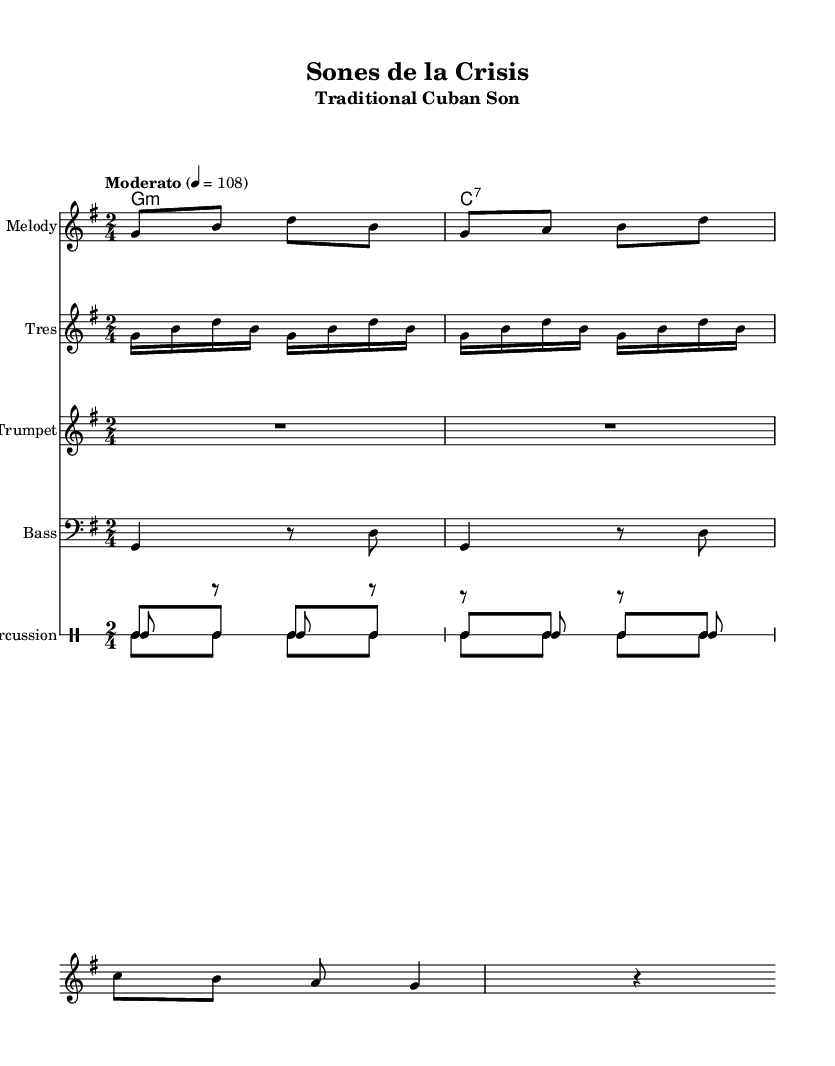What is the key signature of this music? The key signature is G major, indicated by one sharp (F#) on the staff.
Answer: G major What is the time signature of this music? The time signature is 2/4, shown at the beginning of the sheet music. This means there are 2 beats in each measure, and the quarter note receives one beat.
Answer: 2/4 What is the tempo marking for this piece? The tempo marking is "Moderato" with a metronome marking of 108 beats per minute, which indicates a moderate speed for the performance.
Answer: Moderato How many measures are in the melody section? Counting the measures in the melody section, there are six measures as denoted by the spacing and notation in the staff.
Answer: Six What primary percussion instruments are used in this piece? The primary percussion instruments used are bongos, maracas, and claves, which are identified under the "Percussion" staff with their respective notation.
Answer: Bongos, maracas, claves What type of chord is indicated at the start of the piece? The chord indicated at the start is G minor, which is shown in chord lettering in the "ChordNames" staff.
Answer: G minor 